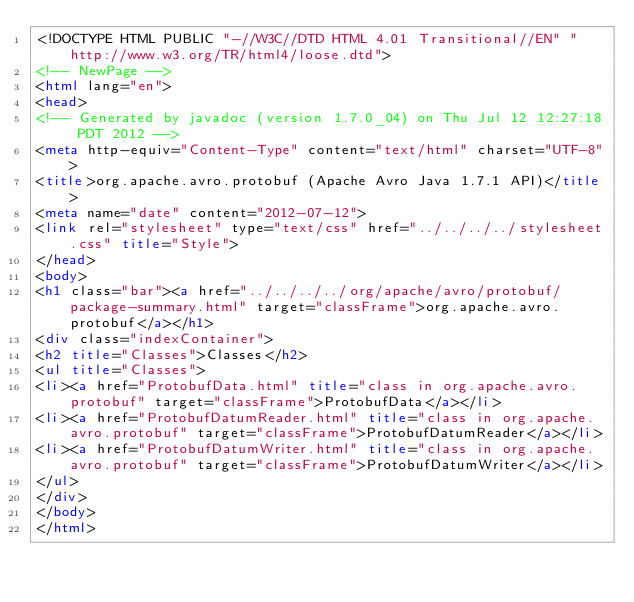<code> <loc_0><loc_0><loc_500><loc_500><_HTML_><!DOCTYPE HTML PUBLIC "-//W3C//DTD HTML 4.01 Transitional//EN" "http://www.w3.org/TR/html4/loose.dtd">
<!-- NewPage -->
<html lang="en">
<head>
<!-- Generated by javadoc (version 1.7.0_04) on Thu Jul 12 12:27:18 PDT 2012 -->
<meta http-equiv="Content-Type" content="text/html" charset="UTF-8">
<title>org.apache.avro.protobuf (Apache Avro Java 1.7.1 API)</title>
<meta name="date" content="2012-07-12">
<link rel="stylesheet" type="text/css" href="../../../../stylesheet.css" title="Style">
</head>
<body>
<h1 class="bar"><a href="../../../../org/apache/avro/protobuf/package-summary.html" target="classFrame">org.apache.avro.protobuf</a></h1>
<div class="indexContainer">
<h2 title="Classes">Classes</h2>
<ul title="Classes">
<li><a href="ProtobufData.html" title="class in org.apache.avro.protobuf" target="classFrame">ProtobufData</a></li>
<li><a href="ProtobufDatumReader.html" title="class in org.apache.avro.protobuf" target="classFrame">ProtobufDatumReader</a></li>
<li><a href="ProtobufDatumWriter.html" title="class in org.apache.avro.protobuf" target="classFrame">ProtobufDatumWriter</a></li>
</ul>
</div>
</body>
</html>
</code> 